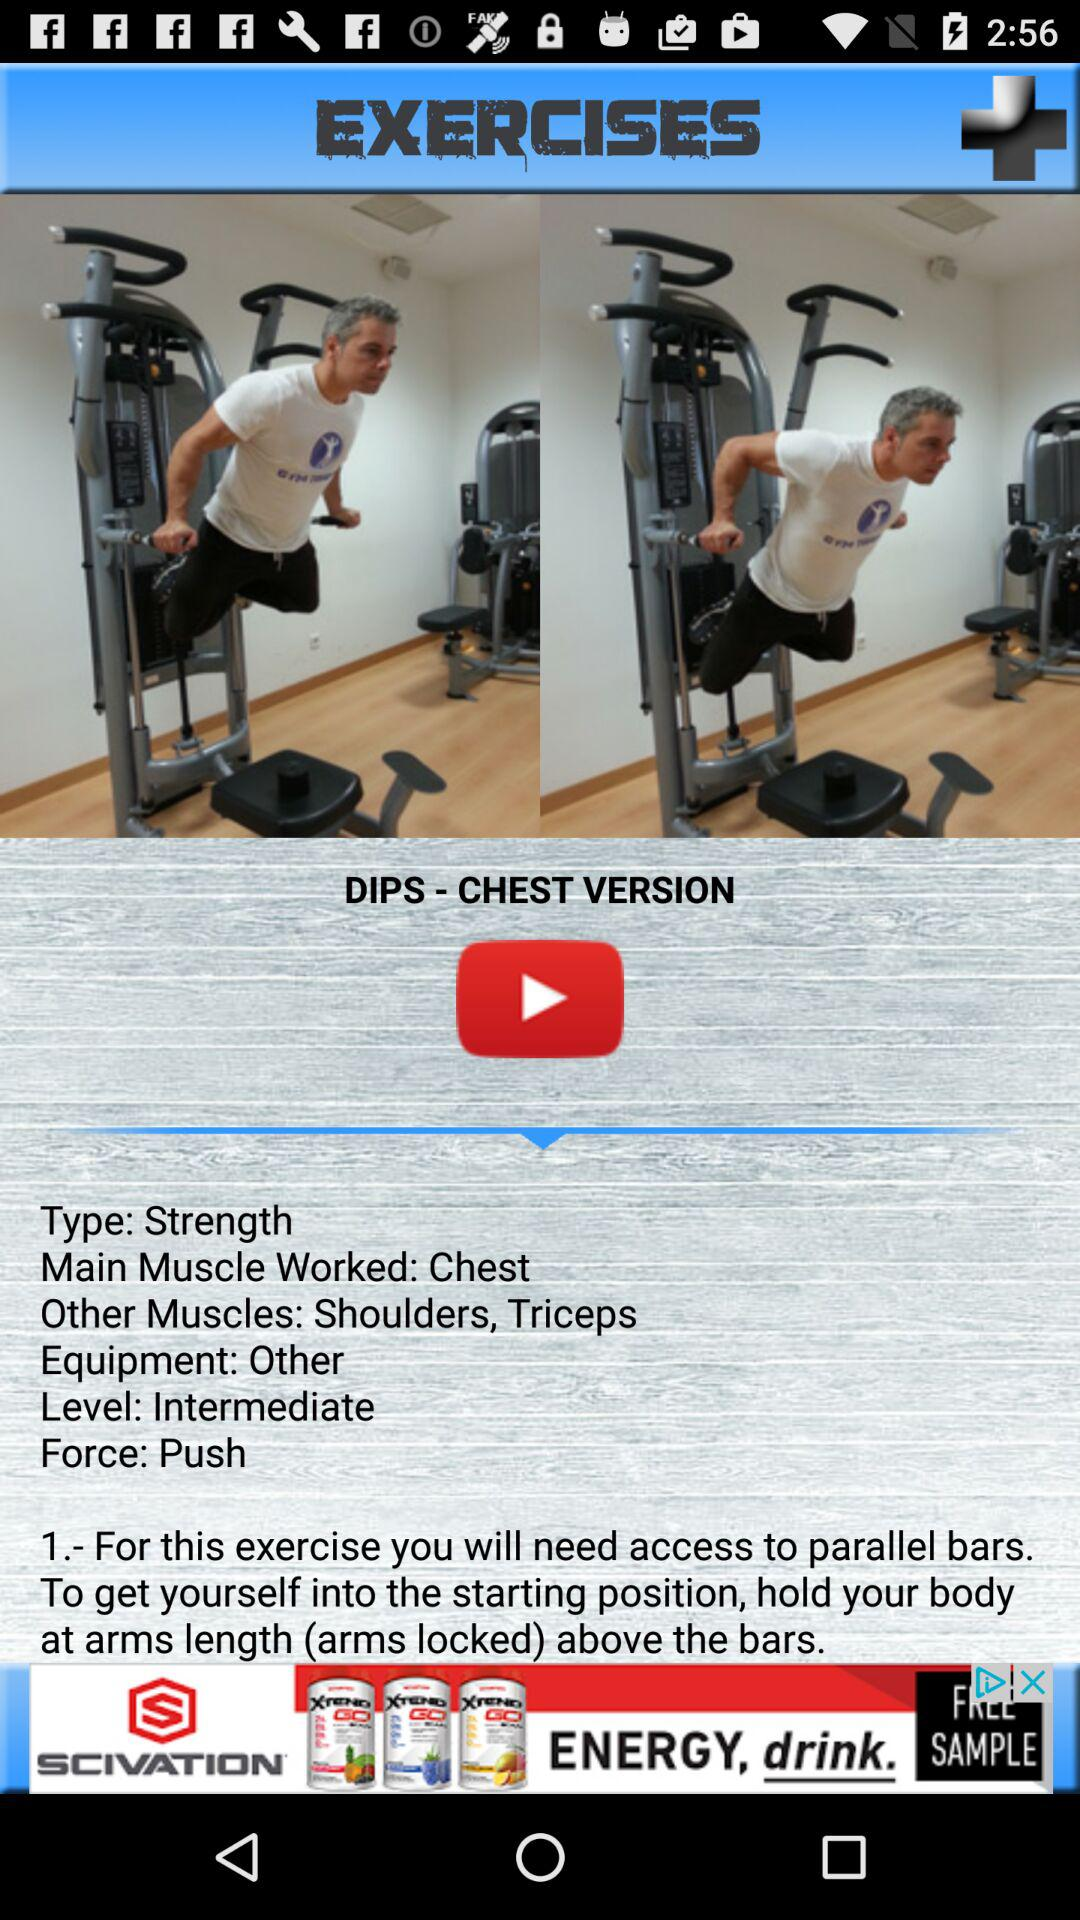What is the main muscle worked in the exercises? The main muscle worked in the exercises is the chest. 